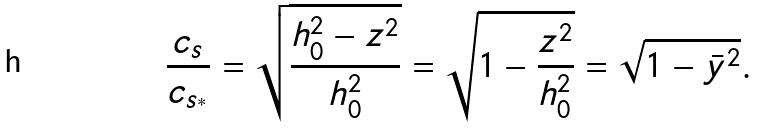<formula> <loc_0><loc_0><loc_500><loc_500>\frac { c _ { s } } { c _ { s _ { ^ { * } } } } = \sqrt { \frac { h _ { 0 } ^ { 2 } - z ^ { 2 } } { h _ { 0 } ^ { 2 } } } = \sqrt { 1 - \frac { z ^ { 2 } } { h _ { 0 } ^ { 2 } } } = \sqrt { 1 - \bar { y } ^ { 2 } } .</formula> 